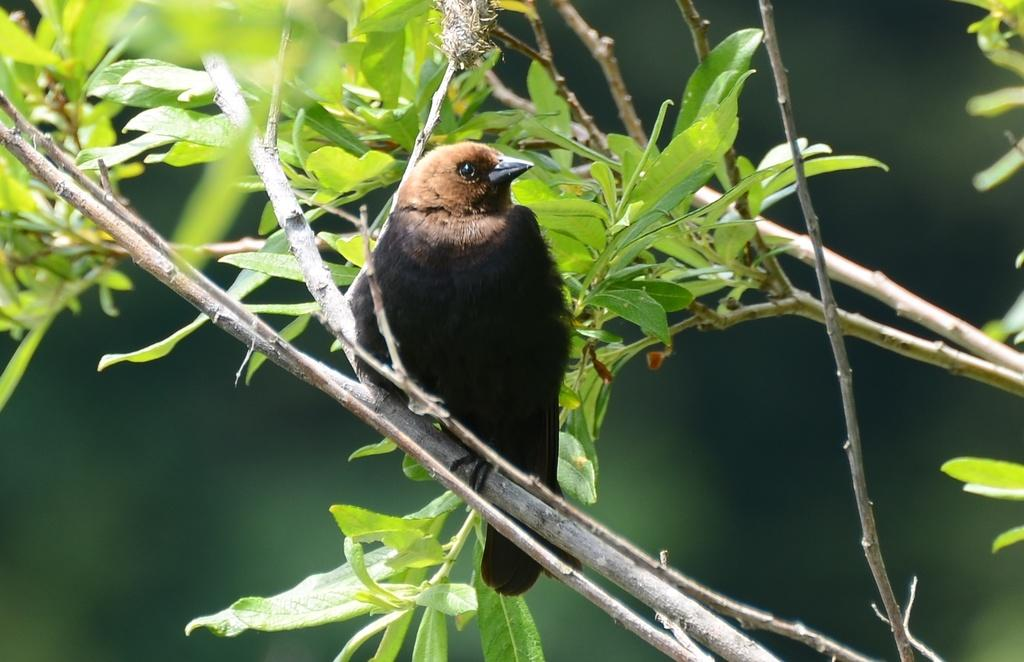What type of animal can be seen in the image? There is a bird in the image. Where is the bird located? The bird is on a tree. Can you describe the background of the image? The background of the image is blurred. What type of glass is the bird drinking from in the image? There is no glass present in the image, and the bird is not shown drinking from anything. 